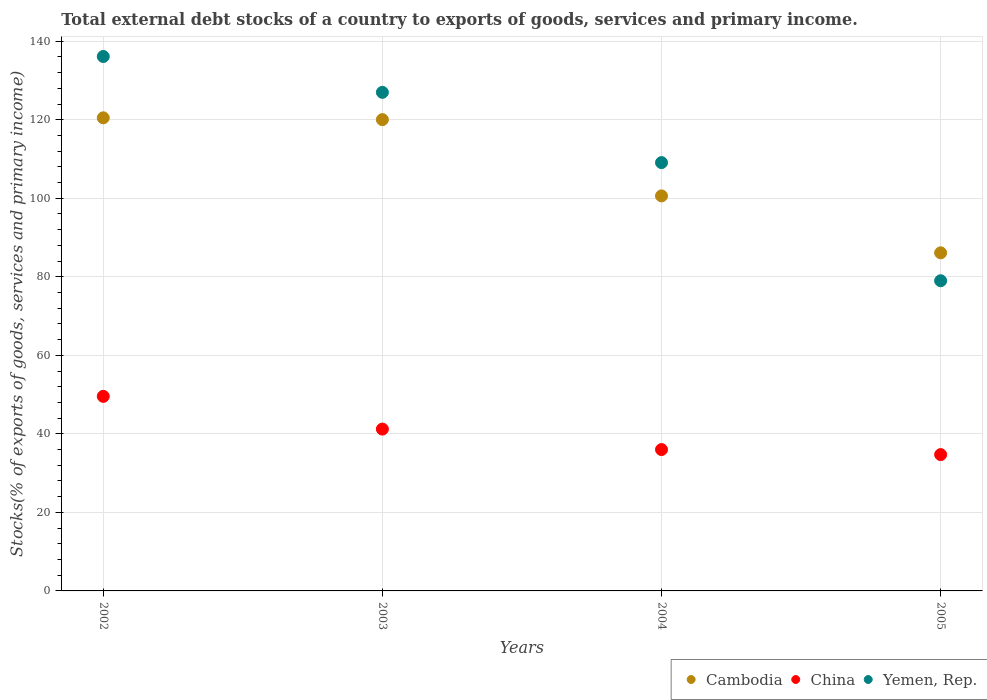What is the total debt stocks in China in 2005?
Ensure brevity in your answer.  34.72. Across all years, what is the maximum total debt stocks in Cambodia?
Ensure brevity in your answer.  120.48. Across all years, what is the minimum total debt stocks in Cambodia?
Give a very brief answer. 86.1. In which year was the total debt stocks in Yemen, Rep. maximum?
Offer a very short reply. 2002. What is the total total debt stocks in Cambodia in the graph?
Give a very brief answer. 427.22. What is the difference between the total debt stocks in Cambodia in 2004 and that in 2005?
Keep it short and to the point. 14.5. What is the difference between the total debt stocks in Cambodia in 2002 and the total debt stocks in Yemen, Rep. in 2003?
Your answer should be compact. -6.49. What is the average total debt stocks in Yemen, Rep. per year?
Give a very brief answer. 112.79. In the year 2004, what is the difference between the total debt stocks in Cambodia and total debt stocks in China?
Provide a succinct answer. 64.6. In how many years, is the total debt stocks in China greater than 136 %?
Provide a short and direct response. 0. What is the ratio of the total debt stocks in Yemen, Rep. in 2003 to that in 2004?
Provide a succinct answer. 1.16. What is the difference between the highest and the second highest total debt stocks in Cambodia?
Provide a succinct answer. 0.46. What is the difference between the highest and the lowest total debt stocks in Yemen, Rep.?
Offer a very short reply. 57.12. In how many years, is the total debt stocks in Yemen, Rep. greater than the average total debt stocks in Yemen, Rep. taken over all years?
Offer a very short reply. 2. Is the sum of the total debt stocks in China in 2003 and 2005 greater than the maximum total debt stocks in Yemen, Rep. across all years?
Offer a terse response. No. Is it the case that in every year, the sum of the total debt stocks in Yemen, Rep. and total debt stocks in Cambodia  is greater than the total debt stocks in China?
Offer a terse response. Yes. Does the total debt stocks in China monotonically increase over the years?
Your answer should be compact. No. Is the total debt stocks in Cambodia strictly greater than the total debt stocks in Yemen, Rep. over the years?
Your answer should be very brief. No. How many dotlines are there?
Offer a very short reply. 3. Are the values on the major ticks of Y-axis written in scientific E-notation?
Make the answer very short. No. Does the graph contain any zero values?
Offer a terse response. No. What is the title of the graph?
Provide a succinct answer. Total external debt stocks of a country to exports of goods, services and primary income. Does "South Africa" appear as one of the legend labels in the graph?
Give a very brief answer. No. What is the label or title of the Y-axis?
Your answer should be compact. Stocks(% of exports of goods, services and primary income). What is the Stocks(% of exports of goods, services and primary income) in Cambodia in 2002?
Keep it short and to the point. 120.48. What is the Stocks(% of exports of goods, services and primary income) of China in 2002?
Your answer should be compact. 49.55. What is the Stocks(% of exports of goods, services and primary income) in Yemen, Rep. in 2002?
Provide a succinct answer. 136.11. What is the Stocks(% of exports of goods, services and primary income) of Cambodia in 2003?
Your response must be concise. 120.03. What is the Stocks(% of exports of goods, services and primary income) in China in 2003?
Your answer should be very brief. 41.21. What is the Stocks(% of exports of goods, services and primary income) in Yemen, Rep. in 2003?
Provide a succinct answer. 126.97. What is the Stocks(% of exports of goods, services and primary income) in Cambodia in 2004?
Keep it short and to the point. 100.6. What is the Stocks(% of exports of goods, services and primary income) of China in 2004?
Give a very brief answer. 36. What is the Stocks(% of exports of goods, services and primary income) of Yemen, Rep. in 2004?
Give a very brief answer. 109.08. What is the Stocks(% of exports of goods, services and primary income) of Cambodia in 2005?
Your answer should be very brief. 86.1. What is the Stocks(% of exports of goods, services and primary income) in China in 2005?
Make the answer very short. 34.72. What is the Stocks(% of exports of goods, services and primary income) in Yemen, Rep. in 2005?
Your response must be concise. 78.99. Across all years, what is the maximum Stocks(% of exports of goods, services and primary income) in Cambodia?
Make the answer very short. 120.48. Across all years, what is the maximum Stocks(% of exports of goods, services and primary income) in China?
Give a very brief answer. 49.55. Across all years, what is the maximum Stocks(% of exports of goods, services and primary income) of Yemen, Rep.?
Keep it short and to the point. 136.11. Across all years, what is the minimum Stocks(% of exports of goods, services and primary income) in Cambodia?
Your answer should be compact. 86.1. Across all years, what is the minimum Stocks(% of exports of goods, services and primary income) of China?
Give a very brief answer. 34.72. Across all years, what is the minimum Stocks(% of exports of goods, services and primary income) in Yemen, Rep.?
Your answer should be very brief. 78.99. What is the total Stocks(% of exports of goods, services and primary income) in Cambodia in the graph?
Ensure brevity in your answer.  427.22. What is the total Stocks(% of exports of goods, services and primary income) of China in the graph?
Your response must be concise. 161.48. What is the total Stocks(% of exports of goods, services and primary income) of Yemen, Rep. in the graph?
Provide a succinct answer. 451.15. What is the difference between the Stocks(% of exports of goods, services and primary income) in Cambodia in 2002 and that in 2003?
Ensure brevity in your answer.  0.46. What is the difference between the Stocks(% of exports of goods, services and primary income) of China in 2002 and that in 2003?
Make the answer very short. 8.34. What is the difference between the Stocks(% of exports of goods, services and primary income) of Yemen, Rep. in 2002 and that in 2003?
Offer a terse response. 9.13. What is the difference between the Stocks(% of exports of goods, services and primary income) of Cambodia in 2002 and that in 2004?
Ensure brevity in your answer.  19.88. What is the difference between the Stocks(% of exports of goods, services and primary income) of China in 2002 and that in 2004?
Provide a short and direct response. 13.55. What is the difference between the Stocks(% of exports of goods, services and primary income) of Yemen, Rep. in 2002 and that in 2004?
Give a very brief answer. 27.03. What is the difference between the Stocks(% of exports of goods, services and primary income) in Cambodia in 2002 and that in 2005?
Offer a very short reply. 34.38. What is the difference between the Stocks(% of exports of goods, services and primary income) in China in 2002 and that in 2005?
Ensure brevity in your answer.  14.84. What is the difference between the Stocks(% of exports of goods, services and primary income) in Yemen, Rep. in 2002 and that in 2005?
Provide a short and direct response. 57.12. What is the difference between the Stocks(% of exports of goods, services and primary income) of Cambodia in 2003 and that in 2004?
Keep it short and to the point. 19.43. What is the difference between the Stocks(% of exports of goods, services and primary income) in China in 2003 and that in 2004?
Give a very brief answer. 5.22. What is the difference between the Stocks(% of exports of goods, services and primary income) of Yemen, Rep. in 2003 and that in 2004?
Offer a very short reply. 17.9. What is the difference between the Stocks(% of exports of goods, services and primary income) in Cambodia in 2003 and that in 2005?
Ensure brevity in your answer.  33.93. What is the difference between the Stocks(% of exports of goods, services and primary income) in China in 2003 and that in 2005?
Provide a short and direct response. 6.5. What is the difference between the Stocks(% of exports of goods, services and primary income) in Yemen, Rep. in 2003 and that in 2005?
Keep it short and to the point. 47.98. What is the difference between the Stocks(% of exports of goods, services and primary income) of Cambodia in 2004 and that in 2005?
Your response must be concise. 14.5. What is the difference between the Stocks(% of exports of goods, services and primary income) in China in 2004 and that in 2005?
Provide a succinct answer. 1.28. What is the difference between the Stocks(% of exports of goods, services and primary income) of Yemen, Rep. in 2004 and that in 2005?
Keep it short and to the point. 30.09. What is the difference between the Stocks(% of exports of goods, services and primary income) of Cambodia in 2002 and the Stocks(% of exports of goods, services and primary income) of China in 2003?
Offer a very short reply. 79.27. What is the difference between the Stocks(% of exports of goods, services and primary income) of Cambodia in 2002 and the Stocks(% of exports of goods, services and primary income) of Yemen, Rep. in 2003?
Your answer should be very brief. -6.49. What is the difference between the Stocks(% of exports of goods, services and primary income) in China in 2002 and the Stocks(% of exports of goods, services and primary income) in Yemen, Rep. in 2003?
Make the answer very short. -77.42. What is the difference between the Stocks(% of exports of goods, services and primary income) in Cambodia in 2002 and the Stocks(% of exports of goods, services and primary income) in China in 2004?
Provide a succinct answer. 84.49. What is the difference between the Stocks(% of exports of goods, services and primary income) in Cambodia in 2002 and the Stocks(% of exports of goods, services and primary income) in Yemen, Rep. in 2004?
Keep it short and to the point. 11.41. What is the difference between the Stocks(% of exports of goods, services and primary income) in China in 2002 and the Stocks(% of exports of goods, services and primary income) in Yemen, Rep. in 2004?
Ensure brevity in your answer.  -59.52. What is the difference between the Stocks(% of exports of goods, services and primary income) of Cambodia in 2002 and the Stocks(% of exports of goods, services and primary income) of China in 2005?
Your answer should be compact. 85.77. What is the difference between the Stocks(% of exports of goods, services and primary income) of Cambodia in 2002 and the Stocks(% of exports of goods, services and primary income) of Yemen, Rep. in 2005?
Your answer should be compact. 41.49. What is the difference between the Stocks(% of exports of goods, services and primary income) in China in 2002 and the Stocks(% of exports of goods, services and primary income) in Yemen, Rep. in 2005?
Ensure brevity in your answer.  -29.44. What is the difference between the Stocks(% of exports of goods, services and primary income) of Cambodia in 2003 and the Stocks(% of exports of goods, services and primary income) of China in 2004?
Keep it short and to the point. 84.03. What is the difference between the Stocks(% of exports of goods, services and primary income) of Cambodia in 2003 and the Stocks(% of exports of goods, services and primary income) of Yemen, Rep. in 2004?
Your answer should be very brief. 10.95. What is the difference between the Stocks(% of exports of goods, services and primary income) in China in 2003 and the Stocks(% of exports of goods, services and primary income) in Yemen, Rep. in 2004?
Make the answer very short. -67.86. What is the difference between the Stocks(% of exports of goods, services and primary income) in Cambodia in 2003 and the Stocks(% of exports of goods, services and primary income) in China in 2005?
Your response must be concise. 85.31. What is the difference between the Stocks(% of exports of goods, services and primary income) of Cambodia in 2003 and the Stocks(% of exports of goods, services and primary income) of Yemen, Rep. in 2005?
Keep it short and to the point. 41.04. What is the difference between the Stocks(% of exports of goods, services and primary income) in China in 2003 and the Stocks(% of exports of goods, services and primary income) in Yemen, Rep. in 2005?
Your answer should be compact. -37.78. What is the difference between the Stocks(% of exports of goods, services and primary income) of Cambodia in 2004 and the Stocks(% of exports of goods, services and primary income) of China in 2005?
Offer a terse response. 65.88. What is the difference between the Stocks(% of exports of goods, services and primary income) in Cambodia in 2004 and the Stocks(% of exports of goods, services and primary income) in Yemen, Rep. in 2005?
Give a very brief answer. 21.61. What is the difference between the Stocks(% of exports of goods, services and primary income) of China in 2004 and the Stocks(% of exports of goods, services and primary income) of Yemen, Rep. in 2005?
Provide a short and direct response. -42.99. What is the average Stocks(% of exports of goods, services and primary income) in Cambodia per year?
Make the answer very short. 106.8. What is the average Stocks(% of exports of goods, services and primary income) of China per year?
Your response must be concise. 40.37. What is the average Stocks(% of exports of goods, services and primary income) in Yemen, Rep. per year?
Make the answer very short. 112.79. In the year 2002, what is the difference between the Stocks(% of exports of goods, services and primary income) of Cambodia and Stocks(% of exports of goods, services and primary income) of China?
Your answer should be very brief. 70.93. In the year 2002, what is the difference between the Stocks(% of exports of goods, services and primary income) of Cambodia and Stocks(% of exports of goods, services and primary income) of Yemen, Rep.?
Provide a succinct answer. -15.62. In the year 2002, what is the difference between the Stocks(% of exports of goods, services and primary income) of China and Stocks(% of exports of goods, services and primary income) of Yemen, Rep.?
Your answer should be compact. -86.56. In the year 2003, what is the difference between the Stocks(% of exports of goods, services and primary income) in Cambodia and Stocks(% of exports of goods, services and primary income) in China?
Ensure brevity in your answer.  78.81. In the year 2003, what is the difference between the Stocks(% of exports of goods, services and primary income) of Cambodia and Stocks(% of exports of goods, services and primary income) of Yemen, Rep.?
Provide a succinct answer. -6.95. In the year 2003, what is the difference between the Stocks(% of exports of goods, services and primary income) of China and Stocks(% of exports of goods, services and primary income) of Yemen, Rep.?
Provide a short and direct response. -85.76. In the year 2004, what is the difference between the Stocks(% of exports of goods, services and primary income) of Cambodia and Stocks(% of exports of goods, services and primary income) of China?
Your answer should be compact. 64.6. In the year 2004, what is the difference between the Stocks(% of exports of goods, services and primary income) of Cambodia and Stocks(% of exports of goods, services and primary income) of Yemen, Rep.?
Provide a short and direct response. -8.48. In the year 2004, what is the difference between the Stocks(% of exports of goods, services and primary income) of China and Stocks(% of exports of goods, services and primary income) of Yemen, Rep.?
Make the answer very short. -73.08. In the year 2005, what is the difference between the Stocks(% of exports of goods, services and primary income) of Cambodia and Stocks(% of exports of goods, services and primary income) of China?
Give a very brief answer. 51.39. In the year 2005, what is the difference between the Stocks(% of exports of goods, services and primary income) of Cambodia and Stocks(% of exports of goods, services and primary income) of Yemen, Rep.?
Offer a very short reply. 7.11. In the year 2005, what is the difference between the Stocks(% of exports of goods, services and primary income) in China and Stocks(% of exports of goods, services and primary income) in Yemen, Rep.?
Ensure brevity in your answer.  -44.27. What is the ratio of the Stocks(% of exports of goods, services and primary income) of Cambodia in 2002 to that in 2003?
Your answer should be very brief. 1. What is the ratio of the Stocks(% of exports of goods, services and primary income) of China in 2002 to that in 2003?
Provide a short and direct response. 1.2. What is the ratio of the Stocks(% of exports of goods, services and primary income) of Yemen, Rep. in 2002 to that in 2003?
Make the answer very short. 1.07. What is the ratio of the Stocks(% of exports of goods, services and primary income) in Cambodia in 2002 to that in 2004?
Offer a terse response. 1.2. What is the ratio of the Stocks(% of exports of goods, services and primary income) of China in 2002 to that in 2004?
Offer a very short reply. 1.38. What is the ratio of the Stocks(% of exports of goods, services and primary income) in Yemen, Rep. in 2002 to that in 2004?
Keep it short and to the point. 1.25. What is the ratio of the Stocks(% of exports of goods, services and primary income) in Cambodia in 2002 to that in 2005?
Offer a very short reply. 1.4. What is the ratio of the Stocks(% of exports of goods, services and primary income) of China in 2002 to that in 2005?
Provide a succinct answer. 1.43. What is the ratio of the Stocks(% of exports of goods, services and primary income) in Yemen, Rep. in 2002 to that in 2005?
Your answer should be very brief. 1.72. What is the ratio of the Stocks(% of exports of goods, services and primary income) in Cambodia in 2003 to that in 2004?
Your answer should be compact. 1.19. What is the ratio of the Stocks(% of exports of goods, services and primary income) of China in 2003 to that in 2004?
Give a very brief answer. 1.14. What is the ratio of the Stocks(% of exports of goods, services and primary income) of Yemen, Rep. in 2003 to that in 2004?
Offer a terse response. 1.16. What is the ratio of the Stocks(% of exports of goods, services and primary income) in Cambodia in 2003 to that in 2005?
Ensure brevity in your answer.  1.39. What is the ratio of the Stocks(% of exports of goods, services and primary income) of China in 2003 to that in 2005?
Your response must be concise. 1.19. What is the ratio of the Stocks(% of exports of goods, services and primary income) in Yemen, Rep. in 2003 to that in 2005?
Provide a short and direct response. 1.61. What is the ratio of the Stocks(% of exports of goods, services and primary income) of Cambodia in 2004 to that in 2005?
Provide a short and direct response. 1.17. What is the ratio of the Stocks(% of exports of goods, services and primary income) of China in 2004 to that in 2005?
Your response must be concise. 1.04. What is the ratio of the Stocks(% of exports of goods, services and primary income) in Yemen, Rep. in 2004 to that in 2005?
Keep it short and to the point. 1.38. What is the difference between the highest and the second highest Stocks(% of exports of goods, services and primary income) of Cambodia?
Provide a short and direct response. 0.46. What is the difference between the highest and the second highest Stocks(% of exports of goods, services and primary income) of China?
Ensure brevity in your answer.  8.34. What is the difference between the highest and the second highest Stocks(% of exports of goods, services and primary income) in Yemen, Rep.?
Give a very brief answer. 9.13. What is the difference between the highest and the lowest Stocks(% of exports of goods, services and primary income) in Cambodia?
Ensure brevity in your answer.  34.38. What is the difference between the highest and the lowest Stocks(% of exports of goods, services and primary income) in China?
Your answer should be very brief. 14.84. What is the difference between the highest and the lowest Stocks(% of exports of goods, services and primary income) of Yemen, Rep.?
Provide a short and direct response. 57.12. 